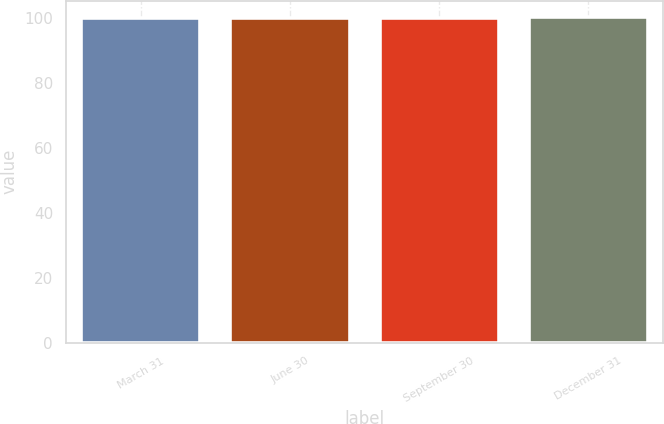Convert chart. <chart><loc_0><loc_0><loc_500><loc_500><bar_chart><fcel>March 31<fcel>June 30<fcel>September 30<fcel>December 31<nl><fcel>100<fcel>100.1<fcel>100.2<fcel>100.3<nl></chart> 